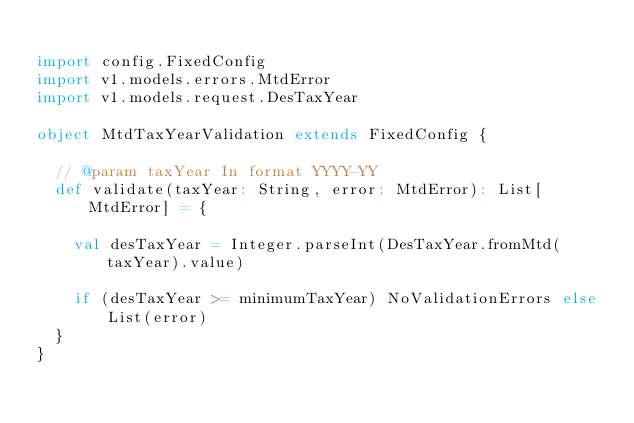Convert code to text. <code><loc_0><loc_0><loc_500><loc_500><_Scala_>
import config.FixedConfig
import v1.models.errors.MtdError
import v1.models.request.DesTaxYear

object MtdTaxYearValidation extends FixedConfig {

  // @param taxYear In format YYYY-YY
  def validate(taxYear: String, error: MtdError): List[MtdError] = {

    val desTaxYear = Integer.parseInt(DesTaxYear.fromMtd(taxYear).value)

    if (desTaxYear >= minimumTaxYear) NoValidationErrors else List(error)
  }
}
</code> 